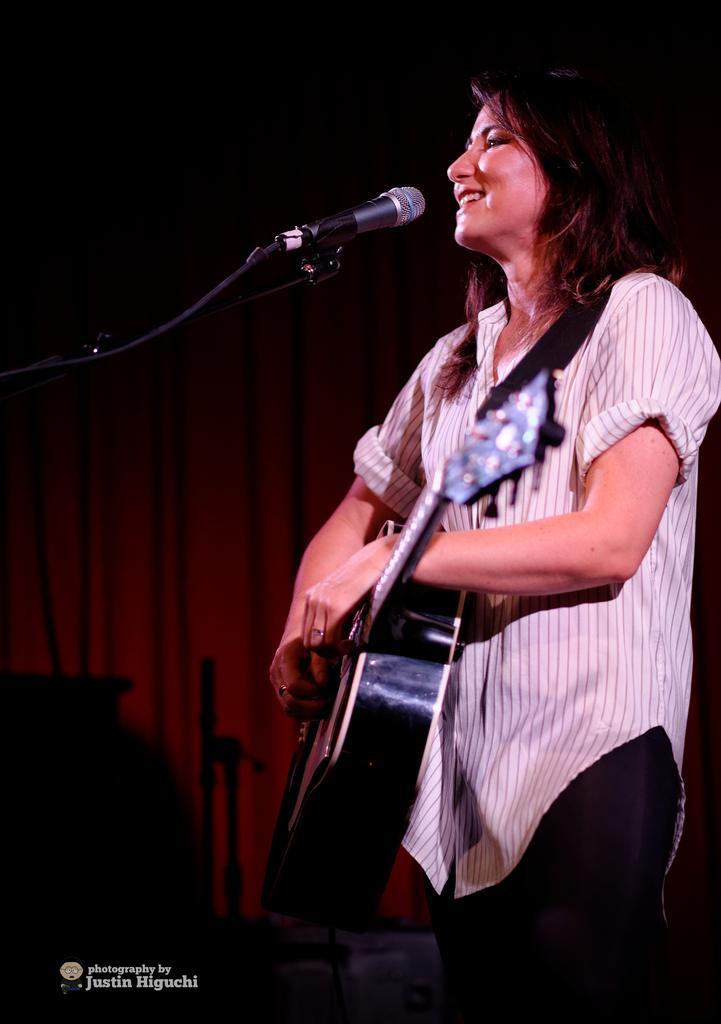How would you summarize this image in a sentence or two? In this image there is a person wearing white color shirt playing guitar in front of her there is a microphone. 